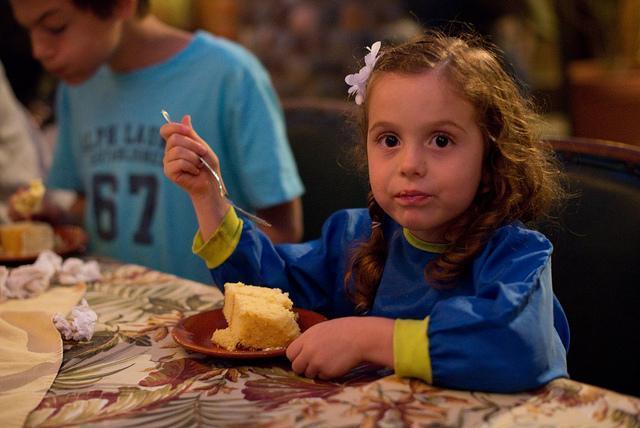How many elbows are on the table?
Give a very brief answer. 2. How many of the children are boys?
Give a very brief answer. 1. How many hot dogs will this person be eating?
Give a very brief answer. 1. How many chairs are in the picture?
Give a very brief answer. 2. How many people can you see?
Give a very brief answer. 3. How many vases are taller than the others?
Give a very brief answer. 0. 